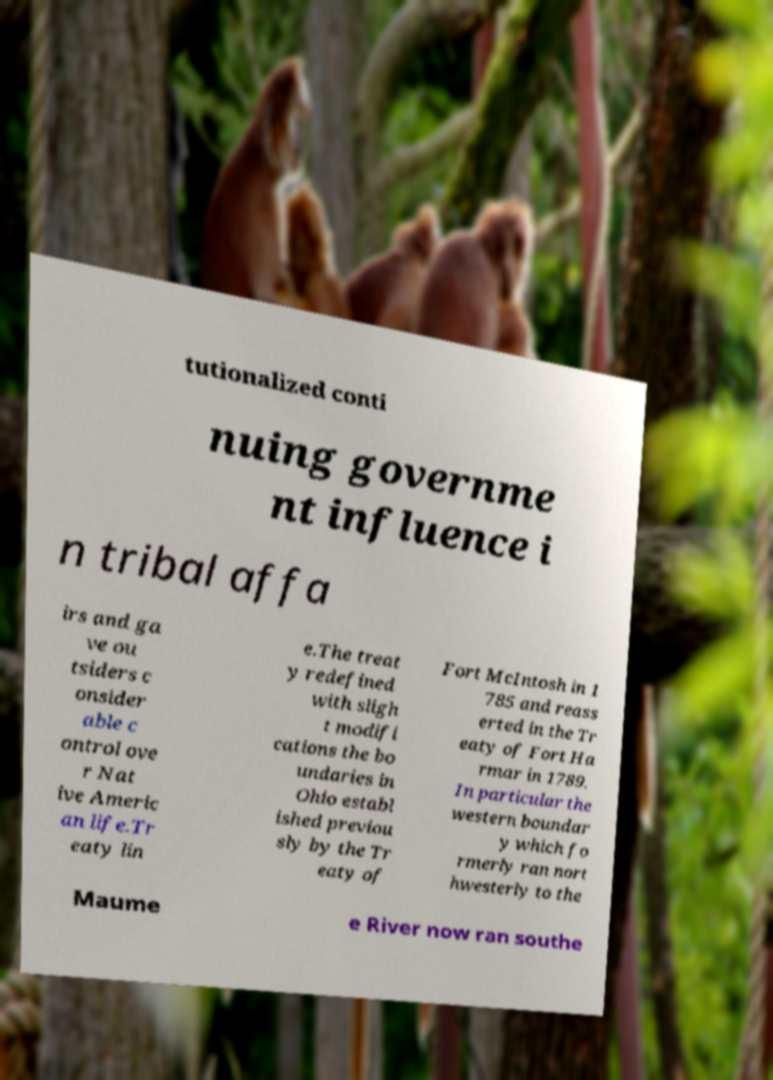What messages or text are displayed in this image? I need them in a readable, typed format. tutionalized conti nuing governme nt influence i n tribal affa irs and ga ve ou tsiders c onsider able c ontrol ove r Nat ive Americ an life.Tr eaty lin e.The treat y redefined with sligh t modifi cations the bo undaries in Ohio establ ished previou sly by the Tr eaty of Fort McIntosh in 1 785 and reass erted in the Tr eaty of Fort Ha rmar in 1789. In particular the western boundar y which fo rmerly ran nort hwesterly to the Maume e River now ran southe 